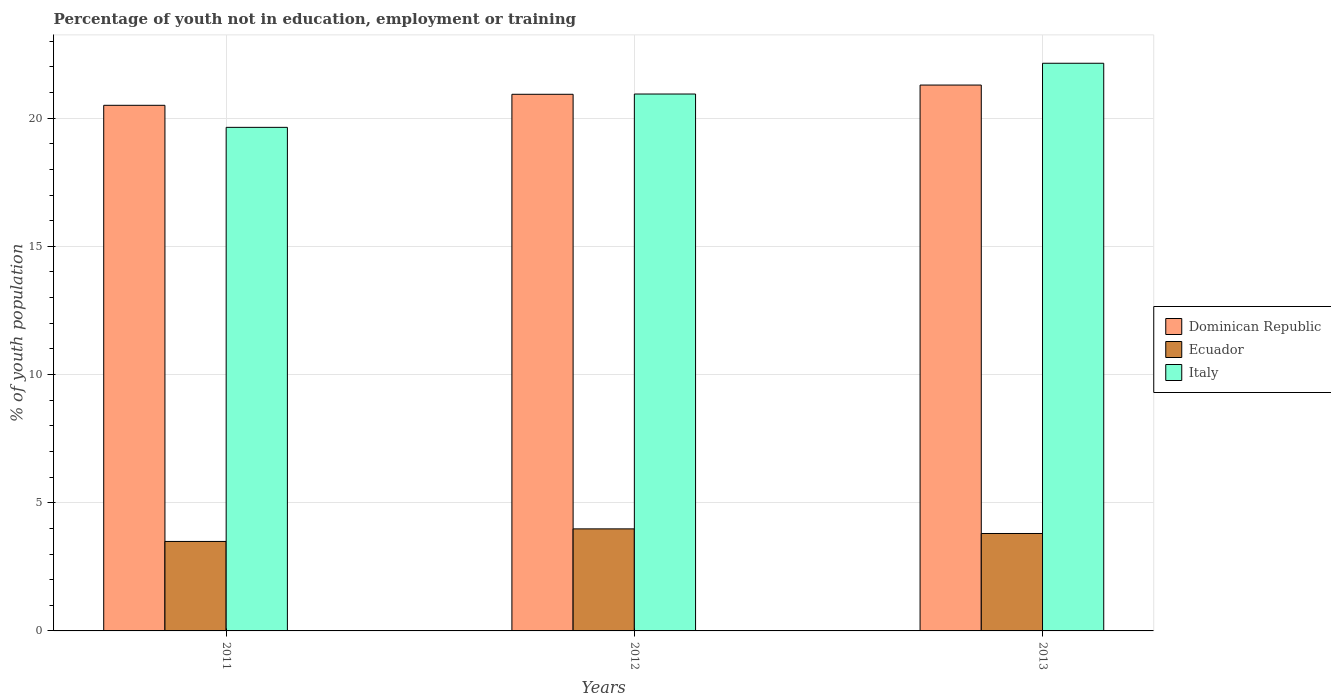How many different coloured bars are there?
Provide a short and direct response. 3. Are the number of bars per tick equal to the number of legend labels?
Your answer should be very brief. Yes. How many bars are there on the 1st tick from the left?
Give a very brief answer. 3. How many bars are there on the 1st tick from the right?
Your response must be concise. 3. What is the label of the 1st group of bars from the left?
Your response must be concise. 2011. In how many cases, is the number of bars for a given year not equal to the number of legend labels?
Make the answer very short. 0. What is the percentage of unemployed youth population in in Dominican Republic in 2012?
Provide a short and direct response. 20.93. Across all years, what is the maximum percentage of unemployed youth population in in Dominican Republic?
Make the answer very short. 21.29. What is the total percentage of unemployed youth population in in Ecuador in the graph?
Your answer should be very brief. 11.27. What is the difference between the percentage of unemployed youth population in in Dominican Republic in 2011 and that in 2012?
Your answer should be very brief. -0.43. What is the difference between the percentage of unemployed youth population in in Italy in 2011 and the percentage of unemployed youth population in in Ecuador in 2012?
Provide a succinct answer. 15.66. What is the average percentage of unemployed youth population in in Dominican Republic per year?
Offer a very short reply. 20.91. In the year 2013, what is the difference between the percentage of unemployed youth population in in Ecuador and percentage of unemployed youth population in in Dominican Republic?
Provide a succinct answer. -17.49. What is the ratio of the percentage of unemployed youth population in in Dominican Republic in 2011 to that in 2012?
Your answer should be compact. 0.98. Is the percentage of unemployed youth population in in Ecuador in 2012 less than that in 2013?
Offer a terse response. No. What is the difference between the highest and the second highest percentage of unemployed youth population in in Dominican Republic?
Make the answer very short. 0.36. What is the difference between the highest and the lowest percentage of unemployed youth population in in Italy?
Provide a succinct answer. 2.5. In how many years, is the percentage of unemployed youth population in in Dominican Republic greater than the average percentage of unemployed youth population in in Dominican Republic taken over all years?
Your answer should be very brief. 2. What does the 2nd bar from the left in 2013 represents?
Provide a short and direct response. Ecuador. What does the 3rd bar from the right in 2013 represents?
Provide a short and direct response. Dominican Republic. Is it the case that in every year, the sum of the percentage of unemployed youth population in in Italy and percentage of unemployed youth population in in Ecuador is greater than the percentage of unemployed youth population in in Dominican Republic?
Ensure brevity in your answer.  Yes. Are all the bars in the graph horizontal?
Your answer should be compact. No. Does the graph contain any zero values?
Offer a terse response. No. Where does the legend appear in the graph?
Offer a terse response. Center right. How many legend labels are there?
Your answer should be compact. 3. What is the title of the graph?
Ensure brevity in your answer.  Percentage of youth not in education, employment or training. Does "Cyprus" appear as one of the legend labels in the graph?
Give a very brief answer. No. What is the label or title of the X-axis?
Give a very brief answer. Years. What is the label or title of the Y-axis?
Provide a short and direct response. % of youth population. What is the % of youth population in Ecuador in 2011?
Keep it short and to the point. 3.49. What is the % of youth population in Italy in 2011?
Provide a succinct answer. 19.64. What is the % of youth population of Dominican Republic in 2012?
Provide a short and direct response. 20.93. What is the % of youth population of Ecuador in 2012?
Your response must be concise. 3.98. What is the % of youth population of Italy in 2012?
Your response must be concise. 20.94. What is the % of youth population of Dominican Republic in 2013?
Keep it short and to the point. 21.29. What is the % of youth population in Ecuador in 2013?
Your response must be concise. 3.8. What is the % of youth population in Italy in 2013?
Your response must be concise. 22.14. Across all years, what is the maximum % of youth population of Dominican Republic?
Ensure brevity in your answer.  21.29. Across all years, what is the maximum % of youth population in Ecuador?
Your answer should be compact. 3.98. Across all years, what is the maximum % of youth population of Italy?
Give a very brief answer. 22.14. Across all years, what is the minimum % of youth population in Dominican Republic?
Ensure brevity in your answer.  20.5. Across all years, what is the minimum % of youth population of Ecuador?
Your response must be concise. 3.49. Across all years, what is the minimum % of youth population in Italy?
Your answer should be very brief. 19.64. What is the total % of youth population of Dominican Republic in the graph?
Keep it short and to the point. 62.72. What is the total % of youth population of Ecuador in the graph?
Your response must be concise. 11.27. What is the total % of youth population in Italy in the graph?
Make the answer very short. 62.72. What is the difference between the % of youth population in Dominican Republic in 2011 and that in 2012?
Provide a succinct answer. -0.43. What is the difference between the % of youth population in Ecuador in 2011 and that in 2012?
Make the answer very short. -0.49. What is the difference between the % of youth population in Dominican Republic in 2011 and that in 2013?
Your answer should be very brief. -0.79. What is the difference between the % of youth population of Ecuador in 2011 and that in 2013?
Your answer should be compact. -0.31. What is the difference between the % of youth population of Dominican Republic in 2012 and that in 2013?
Ensure brevity in your answer.  -0.36. What is the difference between the % of youth population in Ecuador in 2012 and that in 2013?
Make the answer very short. 0.18. What is the difference between the % of youth population of Italy in 2012 and that in 2013?
Offer a terse response. -1.2. What is the difference between the % of youth population in Dominican Republic in 2011 and the % of youth population in Ecuador in 2012?
Provide a succinct answer. 16.52. What is the difference between the % of youth population of Dominican Republic in 2011 and the % of youth population of Italy in 2012?
Provide a succinct answer. -0.44. What is the difference between the % of youth population of Ecuador in 2011 and the % of youth population of Italy in 2012?
Your answer should be very brief. -17.45. What is the difference between the % of youth population in Dominican Republic in 2011 and the % of youth population in Italy in 2013?
Ensure brevity in your answer.  -1.64. What is the difference between the % of youth population of Ecuador in 2011 and the % of youth population of Italy in 2013?
Offer a terse response. -18.65. What is the difference between the % of youth population of Dominican Republic in 2012 and the % of youth population of Ecuador in 2013?
Your answer should be very brief. 17.13. What is the difference between the % of youth population of Dominican Republic in 2012 and the % of youth population of Italy in 2013?
Make the answer very short. -1.21. What is the difference between the % of youth population of Ecuador in 2012 and the % of youth population of Italy in 2013?
Ensure brevity in your answer.  -18.16. What is the average % of youth population of Dominican Republic per year?
Ensure brevity in your answer.  20.91. What is the average % of youth population in Ecuador per year?
Offer a very short reply. 3.76. What is the average % of youth population in Italy per year?
Your answer should be compact. 20.91. In the year 2011, what is the difference between the % of youth population in Dominican Republic and % of youth population in Ecuador?
Provide a succinct answer. 17.01. In the year 2011, what is the difference between the % of youth population in Dominican Republic and % of youth population in Italy?
Your answer should be compact. 0.86. In the year 2011, what is the difference between the % of youth population of Ecuador and % of youth population of Italy?
Provide a short and direct response. -16.15. In the year 2012, what is the difference between the % of youth population in Dominican Republic and % of youth population in Ecuador?
Offer a terse response. 16.95. In the year 2012, what is the difference between the % of youth population in Dominican Republic and % of youth population in Italy?
Make the answer very short. -0.01. In the year 2012, what is the difference between the % of youth population in Ecuador and % of youth population in Italy?
Ensure brevity in your answer.  -16.96. In the year 2013, what is the difference between the % of youth population of Dominican Republic and % of youth population of Ecuador?
Offer a very short reply. 17.49. In the year 2013, what is the difference between the % of youth population of Dominican Republic and % of youth population of Italy?
Make the answer very short. -0.85. In the year 2013, what is the difference between the % of youth population of Ecuador and % of youth population of Italy?
Your response must be concise. -18.34. What is the ratio of the % of youth population in Dominican Republic in 2011 to that in 2012?
Provide a succinct answer. 0.98. What is the ratio of the % of youth population in Ecuador in 2011 to that in 2012?
Your answer should be compact. 0.88. What is the ratio of the % of youth population of Italy in 2011 to that in 2012?
Make the answer very short. 0.94. What is the ratio of the % of youth population of Dominican Republic in 2011 to that in 2013?
Your answer should be compact. 0.96. What is the ratio of the % of youth population in Ecuador in 2011 to that in 2013?
Provide a short and direct response. 0.92. What is the ratio of the % of youth population of Italy in 2011 to that in 2013?
Ensure brevity in your answer.  0.89. What is the ratio of the % of youth population in Dominican Republic in 2012 to that in 2013?
Provide a short and direct response. 0.98. What is the ratio of the % of youth population in Ecuador in 2012 to that in 2013?
Make the answer very short. 1.05. What is the ratio of the % of youth population of Italy in 2012 to that in 2013?
Your answer should be compact. 0.95. What is the difference between the highest and the second highest % of youth population in Dominican Republic?
Your answer should be compact. 0.36. What is the difference between the highest and the second highest % of youth population in Ecuador?
Offer a terse response. 0.18. What is the difference between the highest and the second highest % of youth population in Italy?
Provide a short and direct response. 1.2. What is the difference between the highest and the lowest % of youth population in Dominican Republic?
Your answer should be very brief. 0.79. What is the difference between the highest and the lowest % of youth population in Ecuador?
Your response must be concise. 0.49. What is the difference between the highest and the lowest % of youth population in Italy?
Offer a terse response. 2.5. 